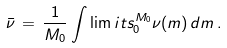Convert formula to latex. <formula><loc_0><loc_0><loc_500><loc_500>\bar { \nu } \, = \, \frac { 1 } { M _ { 0 } } \int \lim i t s _ { 0 } ^ { M _ { 0 } } \nu ( m ) \, d m \, .</formula> 